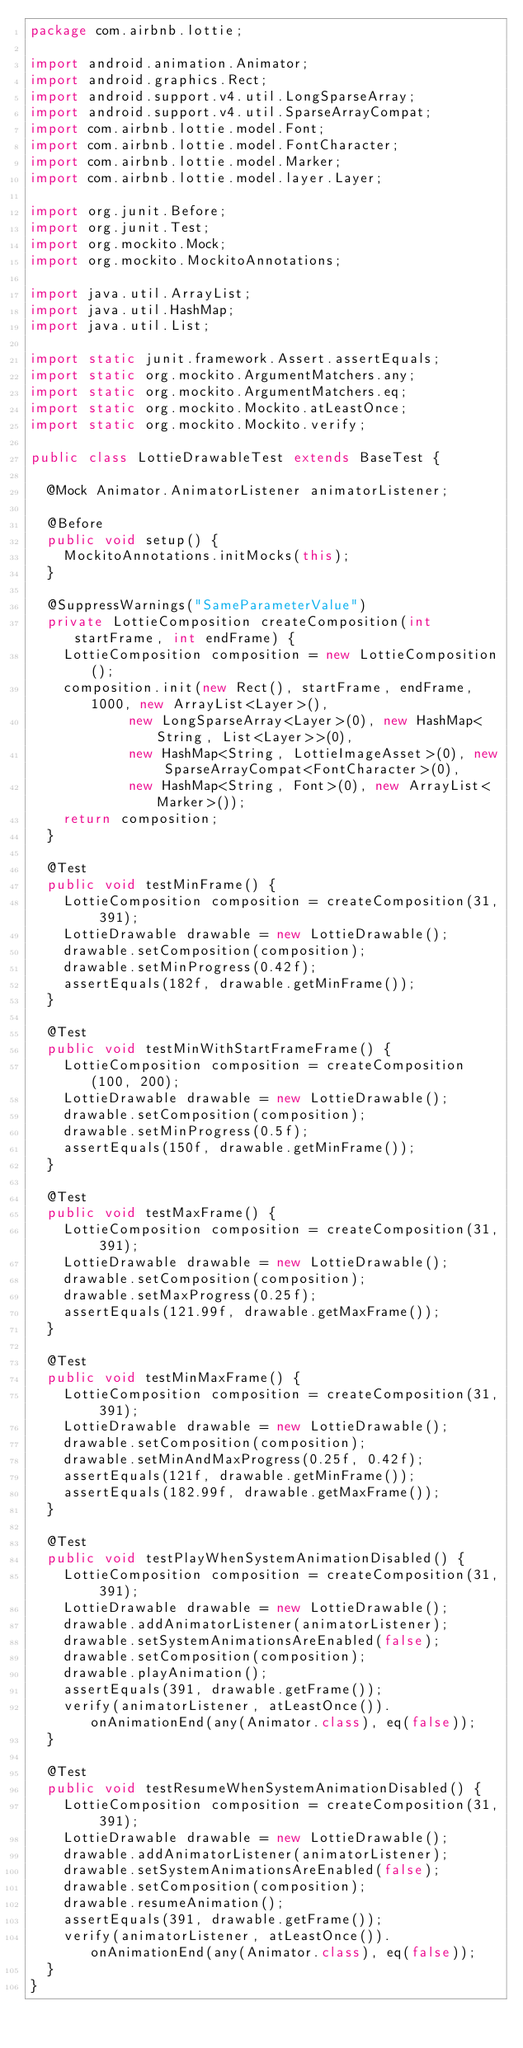<code> <loc_0><loc_0><loc_500><loc_500><_Java_>package com.airbnb.lottie;

import android.animation.Animator;
import android.graphics.Rect;
import android.support.v4.util.LongSparseArray;
import android.support.v4.util.SparseArrayCompat;
import com.airbnb.lottie.model.Font;
import com.airbnb.lottie.model.FontCharacter;
import com.airbnb.lottie.model.Marker;
import com.airbnb.lottie.model.layer.Layer;

import org.junit.Before;
import org.junit.Test;
import org.mockito.Mock;
import org.mockito.MockitoAnnotations;

import java.util.ArrayList;
import java.util.HashMap;
import java.util.List;

import static junit.framework.Assert.assertEquals;
import static org.mockito.ArgumentMatchers.any;
import static org.mockito.ArgumentMatchers.eq;
import static org.mockito.Mockito.atLeastOnce;
import static org.mockito.Mockito.verify;

public class LottieDrawableTest extends BaseTest {

  @Mock Animator.AnimatorListener animatorListener;

  @Before
  public void setup() {
    MockitoAnnotations.initMocks(this);
  }

  @SuppressWarnings("SameParameterValue")
  private LottieComposition createComposition(int startFrame, int endFrame) {
    LottieComposition composition = new LottieComposition();
    composition.init(new Rect(), startFrame, endFrame, 1000, new ArrayList<Layer>(),
            new LongSparseArray<Layer>(0), new HashMap<String, List<Layer>>(0),
            new HashMap<String, LottieImageAsset>(0), new SparseArrayCompat<FontCharacter>(0),
            new HashMap<String, Font>(0), new ArrayList<Marker>());
    return composition;
  }

  @Test
  public void testMinFrame() {
    LottieComposition composition = createComposition(31, 391);
    LottieDrawable drawable = new LottieDrawable();
    drawable.setComposition(composition);
    drawable.setMinProgress(0.42f);
    assertEquals(182f, drawable.getMinFrame());
  }

  @Test
  public void testMinWithStartFrameFrame() {
    LottieComposition composition = createComposition(100, 200);
    LottieDrawable drawable = new LottieDrawable();
    drawable.setComposition(composition);
    drawable.setMinProgress(0.5f);
    assertEquals(150f, drawable.getMinFrame());
  }

  @Test
  public void testMaxFrame() {
    LottieComposition composition = createComposition(31, 391);
    LottieDrawable drawable = new LottieDrawable();
    drawable.setComposition(composition);
    drawable.setMaxProgress(0.25f);
    assertEquals(121.99f, drawable.getMaxFrame());
  }

  @Test
  public void testMinMaxFrame() {
    LottieComposition composition = createComposition(31, 391);
    LottieDrawable drawable = new LottieDrawable();
    drawable.setComposition(composition);
    drawable.setMinAndMaxProgress(0.25f, 0.42f);
    assertEquals(121f, drawable.getMinFrame());
    assertEquals(182.99f, drawable.getMaxFrame());
  }

  @Test
  public void testPlayWhenSystemAnimationDisabled() {
    LottieComposition composition = createComposition(31, 391);
    LottieDrawable drawable = new LottieDrawable();
    drawable.addAnimatorListener(animatorListener);
    drawable.setSystemAnimationsAreEnabled(false);
    drawable.setComposition(composition);
    drawable.playAnimation();
    assertEquals(391, drawable.getFrame());
    verify(animatorListener, atLeastOnce()).onAnimationEnd(any(Animator.class), eq(false));
  }

  @Test
  public void testResumeWhenSystemAnimationDisabled() {
    LottieComposition composition = createComposition(31, 391);
    LottieDrawable drawable = new LottieDrawable();
    drawable.addAnimatorListener(animatorListener);
    drawable.setSystemAnimationsAreEnabled(false);
    drawable.setComposition(composition);
    drawable.resumeAnimation();
    assertEquals(391, drawable.getFrame());
    verify(animatorListener, atLeastOnce()).onAnimationEnd(any(Animator.class), eq(false));
  }
}
</code> 